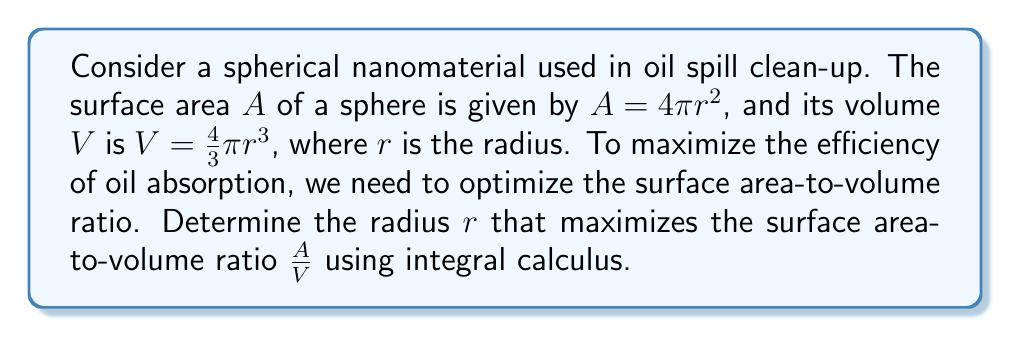Show me your answer to this math problem. 1) First, let's express the surface area-to-volume ratio as a function of $r$:

   $$\frac{A}{V} = \frac{4\pi r^2}{\frac{4}{3}\pi r^3} = \frac{3}{r}$$

2) To find the maximum, we need to find where the derivative of this function equals zero. However, this function is already in its simplest form and its derivative will always be negative. This means the function is strictly decreasing, and the maximum occurs at the smallest possible value of $r$.

3) In the context of nanomaterials, we're dealing with extremely small particles. The smallest possible radius would be that of a single atom. However, to use calculus, we'll consider $r$ as a continuous variable approaching zero.

4) To formalize this using integral calculus, we can consider the average value of the function over an interval $[a, b]$:

   $$\text{Average} = \frac{1}{b-a}\int_a^b \frac{3}{r} dr$$

5) Evaluating this integral:

   $$\frac{1}{b-a}\int_a^b \frac{3}{r} dr = \frac{1}{b-a}[3\ln|r|]_a^b = \frac{3}{b-a}(\ln b - \ln a)$$

6) As we let $a$ approach zero (keeping $b$ fixed), this average value grows without bound:

   $$\lim_{a \to 0^+} \frac{3}{b-a}(\ln b - \ln a) = \infty$$

7) This confirms that the surface area-to-volume ratio is maximized as the radius approaches zero.
Answer: The optimal radius approaches 0. 